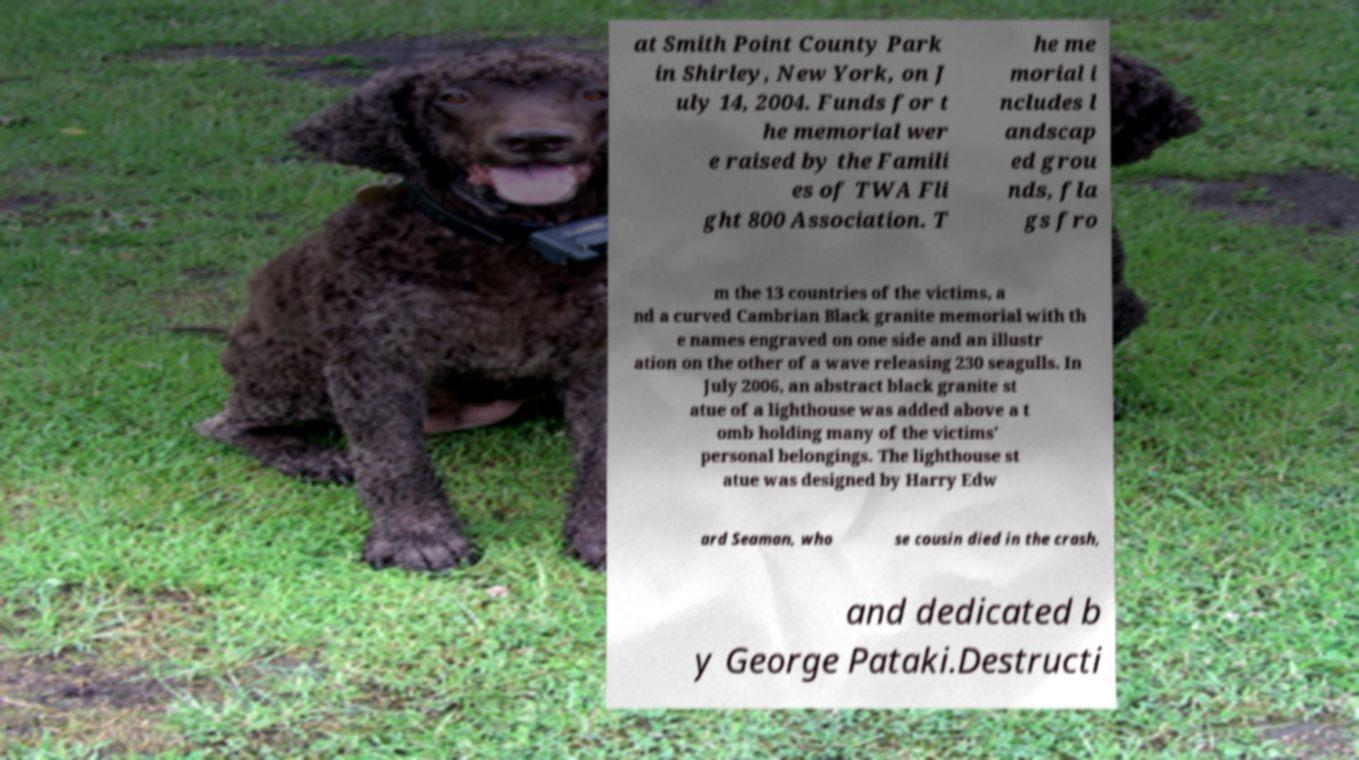Please read and relay the text visible in this image. What does it say? at Smith Point County Park in Shirley, New York, on J uly 14, 2004. Funds for t he memorial wer e raised by the Famili es of TWA Fli ght 800 Association. T he me morial i ncludes l andscap ed grou nds, fla gs fro m the 13 countries of the victims, a nd a curved Cambrian Black granite memorial with th e names engraved on one side and an illustr ation on the other of a wave releasing 230 seagulls. In July 2006, an abstract black granite st atue of a lighthouse was added above a t omb holding many of the victims' personal belongings. The lighthouse st atue was designed by Harry Edw ard Seaman, who se cousin died in the crash, and dedicated b y George Pataki.Destructi 